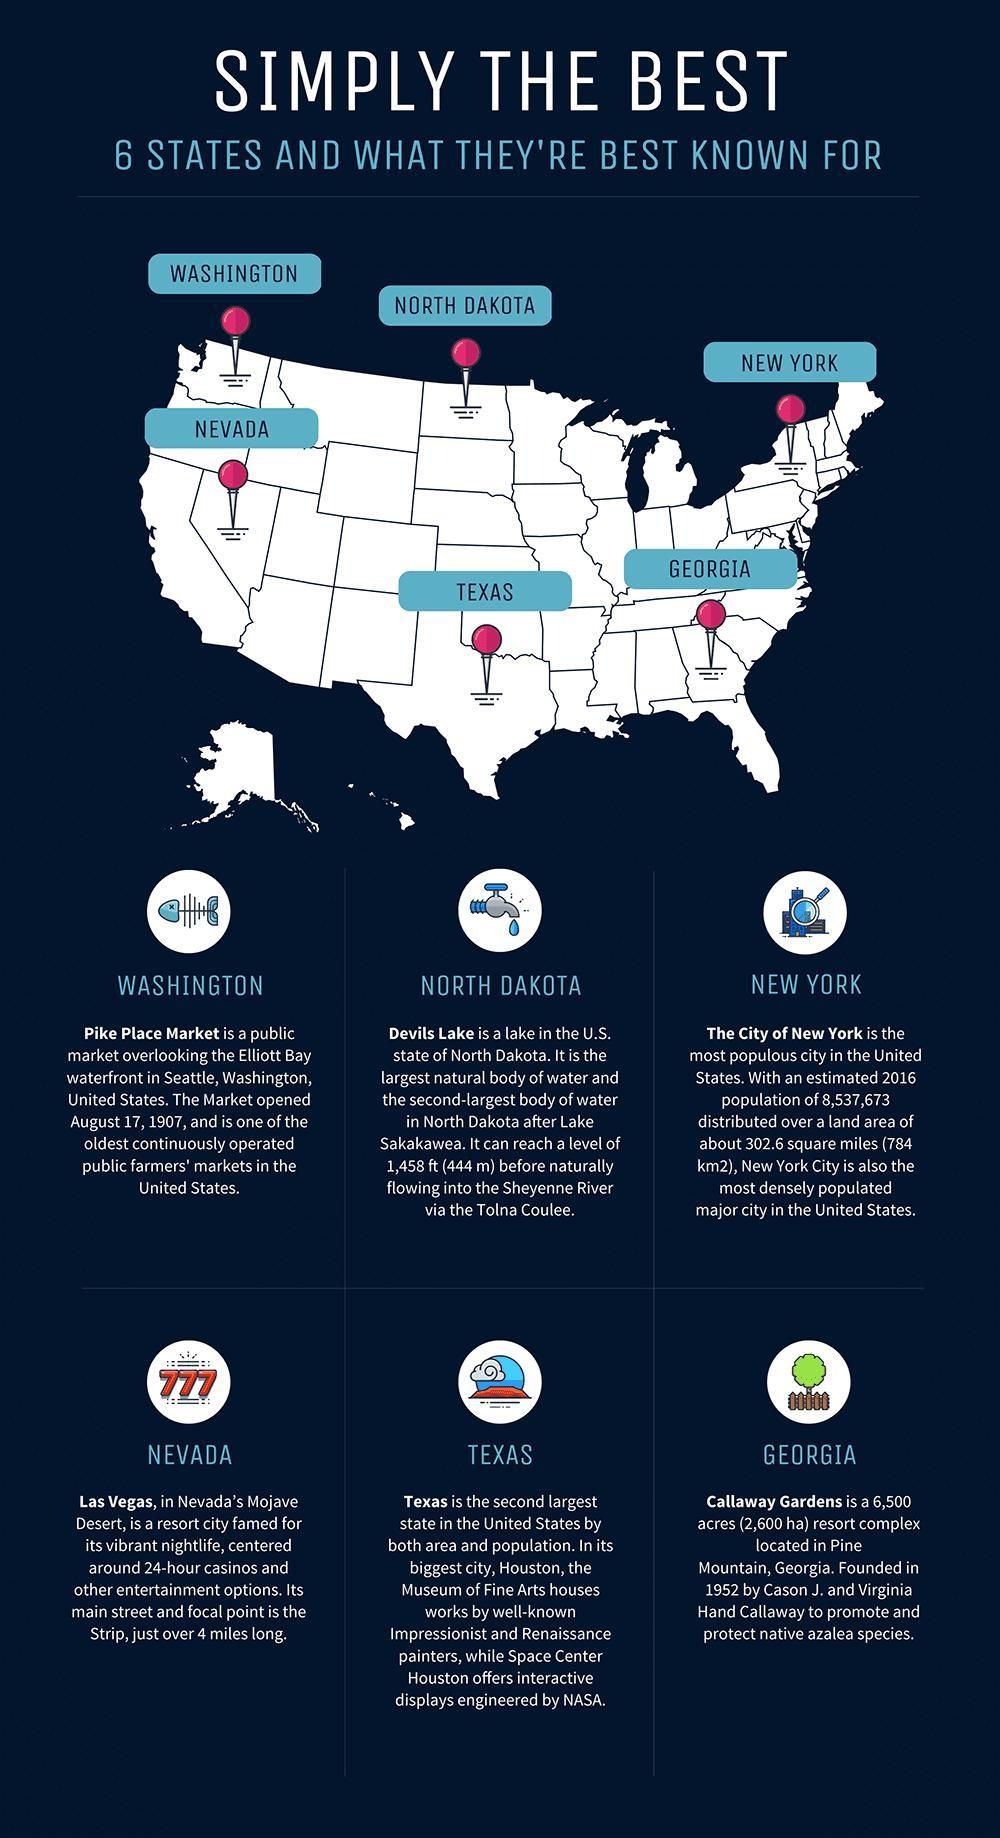Which is the second largest state in the United States?
Answer the question with a short phrase. Texas When was the Pike Place Market opened in the United States? August 17, 1907 Which lake is the second largest natural body of water in the U.S. state of North Dakota? Devils Lake What is the estimated population of New York in the year 2016? 8,537,673 